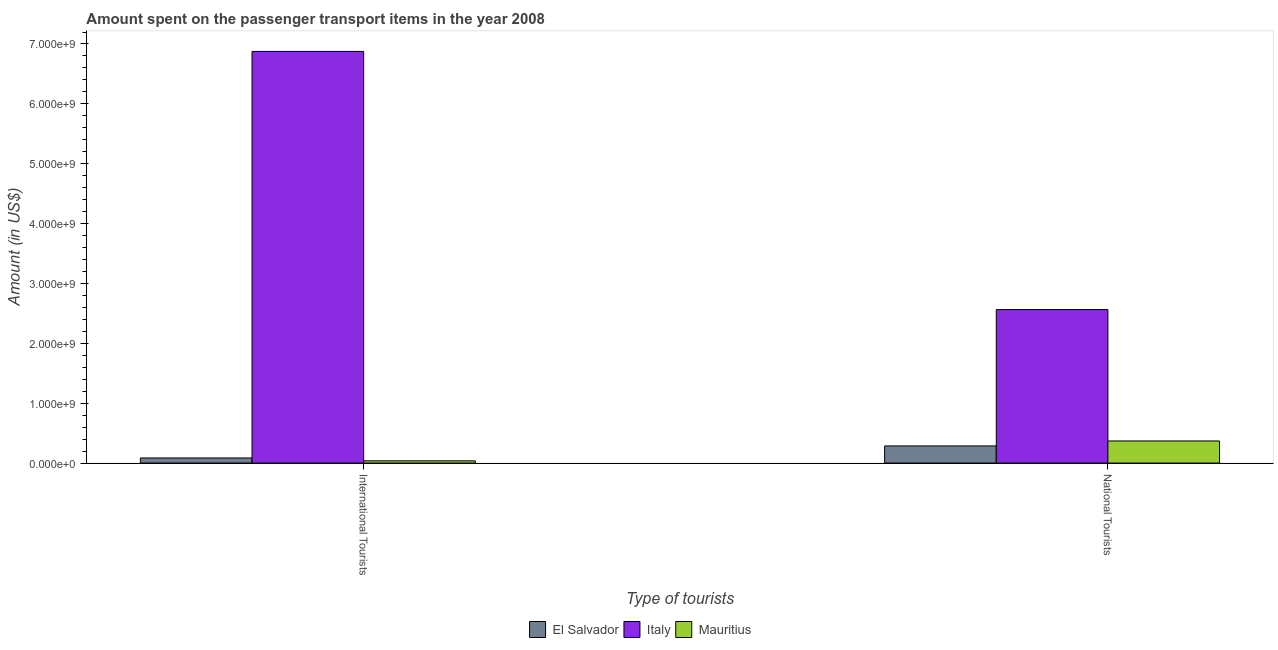How many different coloured bars are there?
Your response must be concise. 3. How many groups of bars are there?
Ensure brevity in your answer.  2. How many bars are there on the 2nd tick from the right?
Keep it short and to the point. 3. What is the label of the 2nd group of bars from the left?
Offer a terse response. National Tourists. What is the amount spent on transport items of international tourists in El Salvador?
Make the answer very short. 8.50e+07. Across all countries, what is the maximum amount spent on transport items of international tourists?
Give a very brief answer. 6.88e+09. Across all countries, what is the minimum amount spent on transport items of international tourists?
Ensure brevity in your answer.  3.70e+07. In which country was the amount spent on transport items of national tourists maximum?
Provide a succinct answer. Italy. In which country was the amount spent on transport items of national tourists minimum?
Provide a short and direct response. El Salvador. What is the total amount spent on transport items of national tourists in the graph?
Your response must be concise. 3.22e+09. What is the difference between the amount spent on transport items of international tourists in Italy and that in El Salvador?
Ensure brevity in your answer.  6.79e+09. What is the difference between the amount spent on transport items of national tourists in Mauritius and the amount spent on transport items of international tourists in El Salvador?
Provide a succinct answer. 2.84e+08. What is the average amount spent on transport items of international tourists per country?
Your response must be concise. 2.33e+09. What is the difference between the amount spent on transport items of international tourists and amount spent on transport items of national tourists in Mauritius?
Offer a terse response. -3.32e+08. What is the ratio of the amount spent on transport items of international tourists in El Salvador to that in Italy?
Provide a short and direct response. 0.01. Is the amount spent on transport items of national tourists in Mauritius less than that in Italy?
Keep it short and to the point. Yes. What does the 1st bar from the left in International Tourists represents?
Ensure brevity in your answer.  El Salvador. What is the difference between two consecutive major ticks on the Y-axis?
Make the answer very short. 1.00e+09. Are the values on the major ticks of Y-axis written in scientific E-notation?
Offer a terse response. Yes. Does the graph contain any zero values?
Ensure brevity in your answer.  No. Does the graph contain grids?
Your response must be concise. No. Where does the legend appear in the graph?
Your response must be concise. Bottom center. How many legend labels are there?
Your answer should be very brief. 3. How are the legend labels stacked?
Your answer should be very brief. Horizontal. What is the title of the graph?
Your answer should be very brief. Amount spent on the passenger transport items in the year 2008. What is the label or title of the X-axis?
Ensure brevity in your answer.  Type of tourists. What is the Amount (in US$) of El Salvador in International Tourists?
Give a very brief answer. 8.50e+07. What is the Amount (in US$) in Italy in International Tourists?
Provide a short and direct response. 6.88e+09. What is the Amount (in US$) in Mauritius in International Tourists?
Keep it short and to the point. 3.70e+07. What is the Amount (in US$) of El Salvador in National Tourists?
Provide a short and direct response. 2.86e+08. What is the Amount (in US$) in Italy in National Tourists?
Your answer should be very brief. 2.56e+09. What is the Amount (in US$) in Mauritius in National Tourists?
Keep it short and to the point. 3.69e+08. Across all Type of tourists, what is the maximum Amount (in US$) in El Salvador?
Your response must be concise. 2.86e+08. Across all Type of tourists, what is the maximum Amount (in US$) in Italy?
Keep it short and to the point. 6.88e+09. Across all Type of tourists, what is the maximum Amount (in US$) in Mauritius?
Give a very brief answer. 3.69e+08. Across all Type of tourists, what is the minimum Amount (in US$) in El Salvador?
Your response must be concise. 8.50e+07. Across all Type of tourists, what is the minimum Amount (in US$) in Italy?
Provide a succinct answer. 2.56e+09. Across all Type of tourists, what is the minimum Amount (in US$) in Mauritius?
Your answer should be very brief. 3.70e+07. What is the total Amount (in US$) in El Salvador in the graph?
Make the answer very short. 3.71e+08. What is the total Amount (in US$) of Italy in the graph?
Provide a short and direct response. 9.44e+09. What is the total Amount (in US$) of Mauritius in the graph?
Offer a very short reply. 4.06e+08. What is the difference between the Amount (in US$) of El Salvador in International Tourists and that in National Tourists?
Your response must be concise. -2.01e+08. What is the difference between the Amount (in US$) of Italy in International Tourists and that in National Tourists?
Keep it short and to the point. 4.31e+09. What is the difference between the Amount (in US$) in Mauritius in International Tourists and that in National Tourists?
Offer a very short reply. -3.32e+08. What is the difference between the Amount (in US$) in El Salvador in International Tourists and the Amount (in US$) in Italy in National Tourists?
Make the answer very short. -2.48e+09. What is the difference between the Amount (in US$) in El Salvador in International Tourists and the Amount (in US$) in Mauritius in National Tourists?
Your answer should be very brief. -2.84e+08. What is the difference between the Amount (in US$) in Italy in International Tourists and the Amount (in US$) in Mauritius in National Tourists?
Your answer should be compact. 6.51e+09. What is the average Amount (in US$) of El Salvador per Type of tourists?
Your response must be concise. 1.86e+08. What is the average Amount (in US$) in Italy per Type of tourists?
Your answer should be very brief. 4.72e+09. What is the average Amount (in US$) of Mauritius per Type of tourists?
Offer a very short reply. 2.03e+08. What is the difference between the Amount (in US$) in El Salvador and Amount (in US$) in Italy in International Tourists?
Offer a very short reply. -6.79e+09. What is the difference between the Amount (in US$) of El Salvador and Amount (in US$) of Mauritius in International Tourists?
Your answer should be very brief. 4.80e+07. What is the difference between the Amount (in US$) of Italy and Amount (in US$) of Mauritius in International Tourists?
Offer a terse response. 6.84e+09. What is the difference between the Amount (in US$) in El Salvador and Amount (in US$) in Italy in National Tourists?
Your answer should be very brief. -2.28e+09. What is the difference between the Amount (in US$) of El Salvador and Amount (in US$) of Mauritius in National Tourists?
Give a very brief answer. -8.30e+07. What is the difference between the Amount (in US$) of Italy and Amount (in US$) of Mauritius in National Tourists?
Your response must be concise. 2.20e+09. What is the ratio of the Amount (in US$) of El Salvador in International Tourists to that in National Tourists?
Make the answer very short. 0.3. What is the ratio of the Amount (in US$) of Italy in International Tourists to that in National Tourists?
Offer a terse response. 2.68. What is the ratio of the Amount (in US$) of Mauritius in International Tourists to that in National Tourists?
Offer a terse response. 0.1. What is the difference between the highest and the second highest Amount (in US$) of El Salvador?
Offer a terse response. 2.01e+08. What is the difference between the highest and the second highest Amount (in US$) of Italy?
Make the answer very short. 4.31e+09. What is the difference between the highest and the second highest Amount (in US$) of Mauritius?
Provide a short and direct response. 3.32e+08. What is the difference between the highest and the lowest Amount (in US$) in El Salvador?
Provide a short and direct response. 2.01e+08. What is the difference between the highest and the lowest Amount (in US$) in Italy?
Offer a terse response. 4.31e+09. What is the difference between the highest and the lowest Amount (in US$) of Mauritius?
Provide a succinct answer. 3.32e+08. 